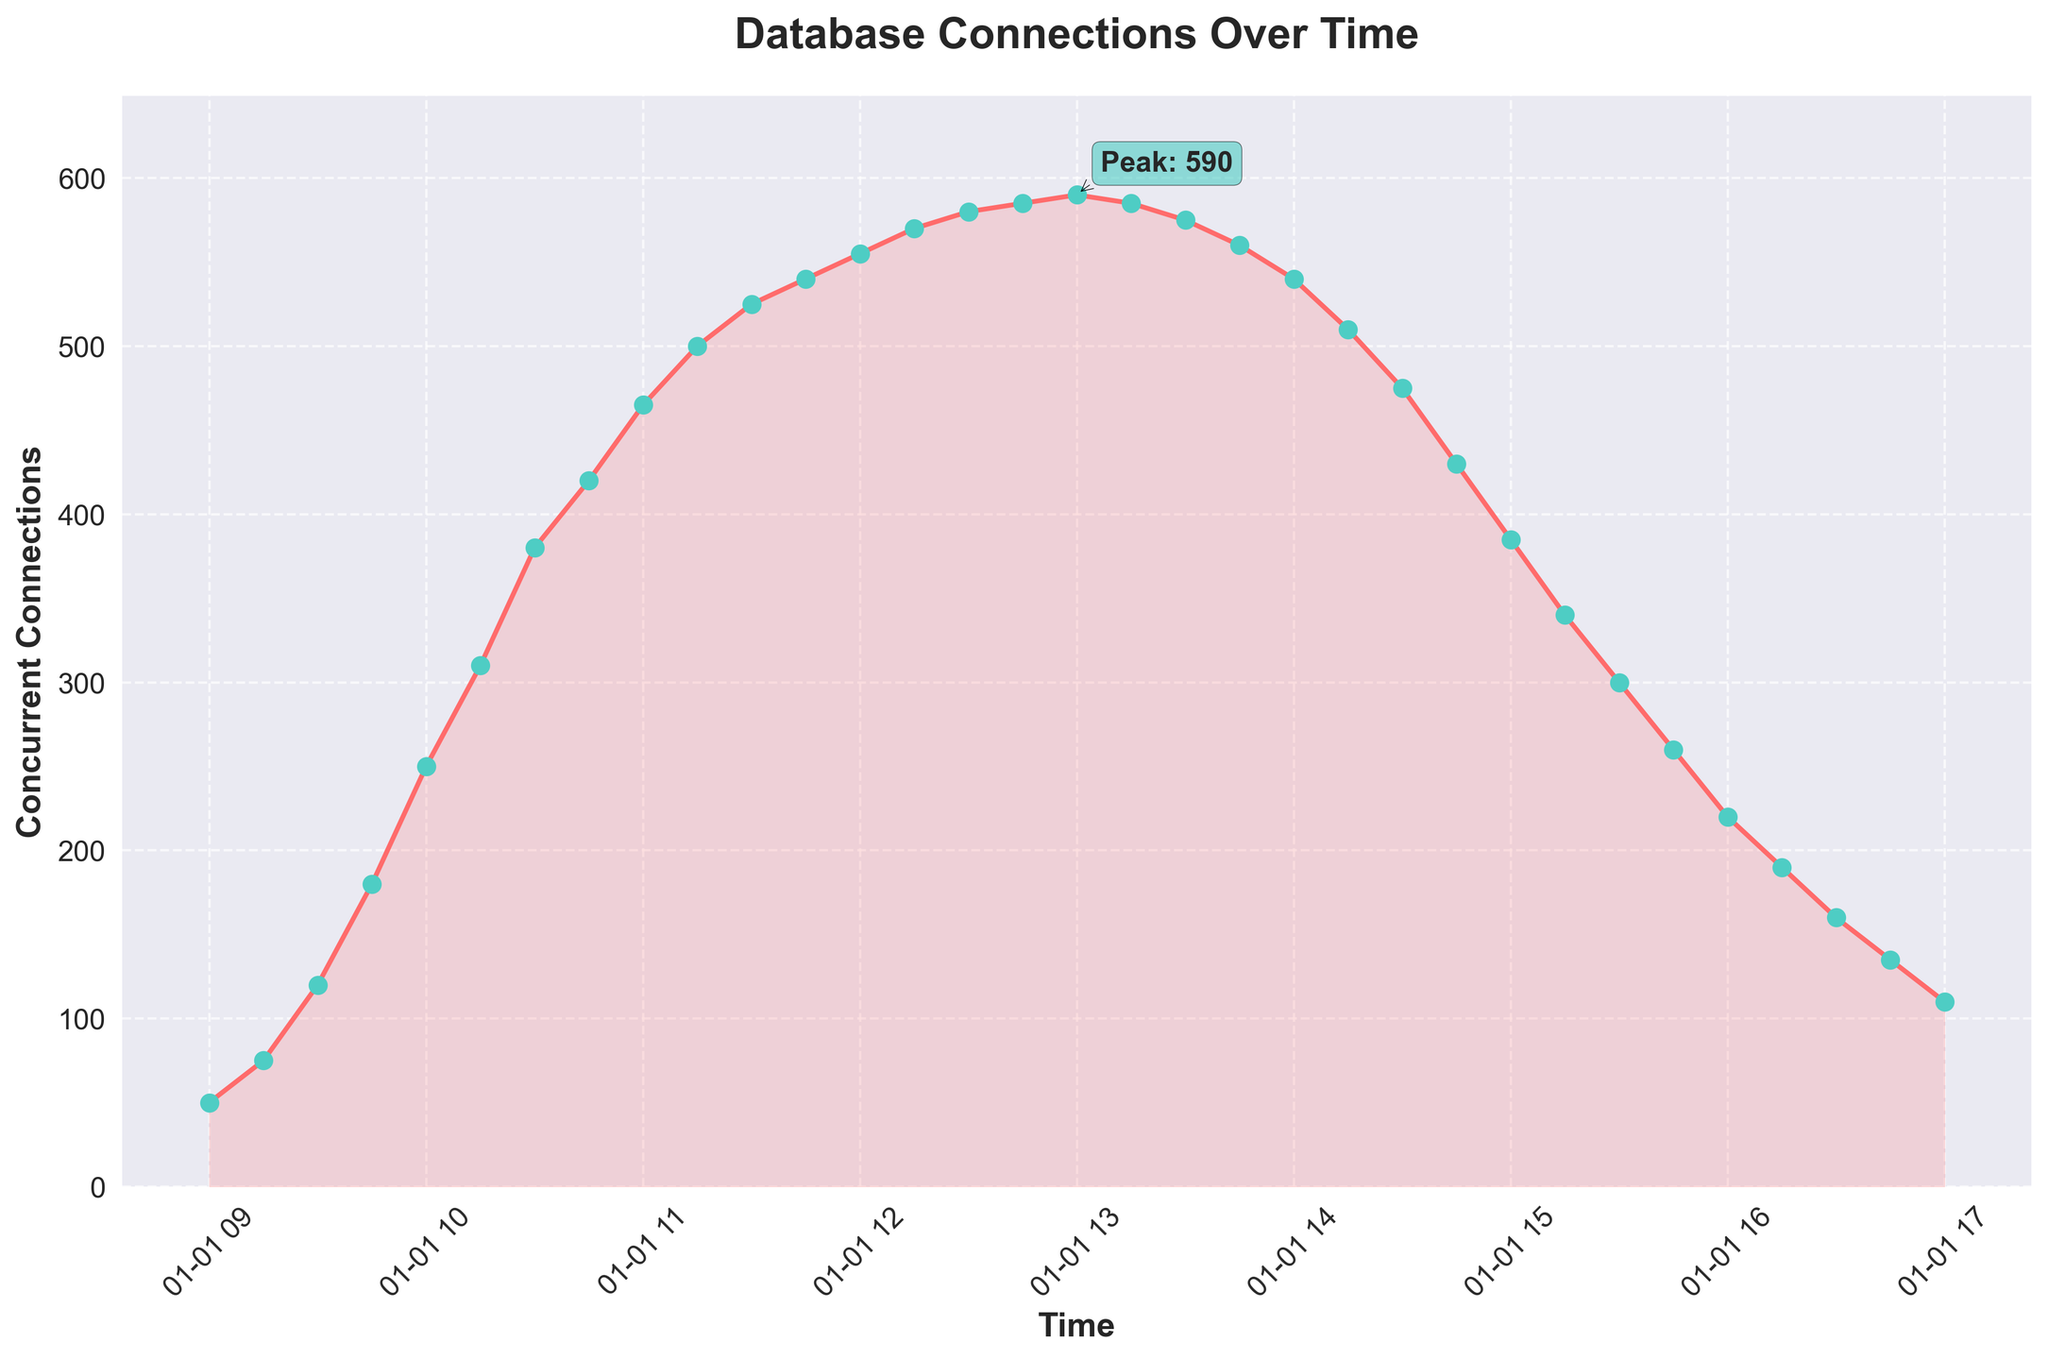What is the peak number of concurrent database connections, and at what time does it occur? The annotation in the figure indicates the peak number of concurrent database connections. The peak number is shown as the highest point on the line, with a label pointing to it.
Answer: 590 at around 13:00 How does the number of concurrent connections change between 09:00 and 11:00? Between 09:00 and 11:00, the number of concurrent connections gradually increases. At 09:00, it starts at 50 and then rises to 465 by 11:00 as seen by following the line from 09:00 to the specified time interval.
Answer: Increases from 50 to 465 What is the trend in the number of concurrent connections from 13:00 to 15:00? Between 13:00 and 15:00, the number of concurrent connections displays a decreasing trend. Observing the line graph, we can see the connections drop from the peak value at 13:00 to lower values as the time approaches 15:00.
Answer: Decreasing trend What time period shows the fastest increase in concurrent connections? By observing the steepness of the line segments, the fastest increase is represented by the segment with the steepest slope. The steepest segment occurs between 09:45 and 10:15, where the number of connections rises sharply.
Answer: Between 09:45 and 10:15 What is the average number of concurrent connections between 12:00 and 13:00? To find the average, sum the concurrent connections at 12:00, 12:15, 12:30, 12:45, and 13:00, then divide by the number of points. The values are 555, 570, 580, 585, and 590. Summing them gives 2880 and the average is 2880/5.
Answer: 576 Compare the number of concurrent connections at 10:30 and 16:30. How do they differ? By checking the line graph, the number of concurrent connections at 10:30 is 380 and at 16:30 it is 160. The difference is calculated by subtracting the smaller value from the larger one: 380 - 160.
Answer: Difference is 220 What visual elements indicate significant changes in the number of concurrent connections? Significant changes are usually indicated by the steepness of the line and annotations. Steeper slopes and highlighted points with annotations on the line graph denote significant changes.
Answer: Steep slopes and annotations What is the difference in the number of concurrent connections between the beginning (09:00) and the end (17:00) of the time window? The number of concurrent connections at 09:00 is 50, and at 17:00 it is 110. The difference is computed by subtracting the former from the latter: 110 - 50.
Answer: Difference is 60 During which hour does the number of concurrent connections exceed 500? By examining the line graph, one can see that the number exceeds 500 at 11:15 and remains above 500 until around 14:00.
Answer: From 11:15 to around 14:00 